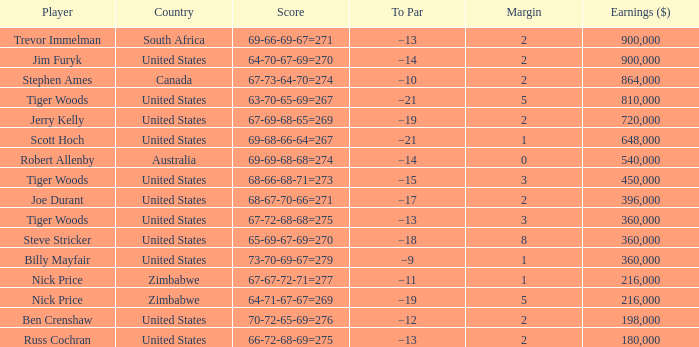How many years has a player such as joe durant experienced, with earnings exceeding $396,000? 0.0. 